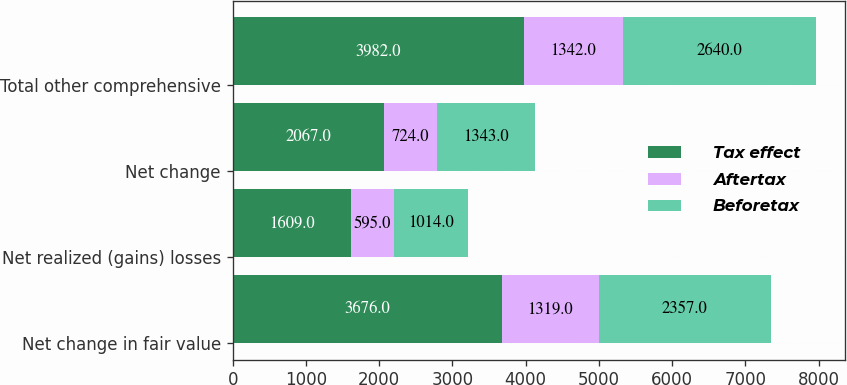Convert chart to OTSL. <chart><loc_0><loc_0><loc_500><loc_500><stacked_bar_chart><ecel><fcel>Net change in fair value<fcel>Net realized (gains) losses<fcel>Net change<fcel>Total other comprehensive<nl><fcel>Tax effect<fcel>3676<fcel>1609<fcel>2067<fcel>3982<nl><fcel>Aftertax<fcel>1319<fcel>595<fcel>724<fcel>1342<nl><fcel>Beforetax<fcel>2357<fcel>1014<fcel>1343<fcel>2640<nl></chart> 